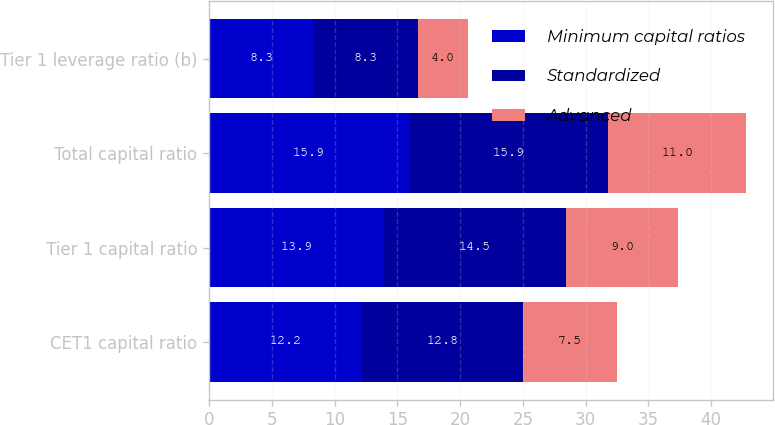Convert chart to OTSL. <chart><loc_0><loc_0><loc_500><loc_500><stacked_bar_chart><ecel><fcel>CET1 capital ratio<fcel>Tier 1 capital ratio<fcel>Total capital ratio<fcel>Tier 1 leverage ratio (b)<nl><fcel>Minimum capital ratios<fcel>12.2<fcel>13.9<fcel>15.9<fcel>8.3<nl><fcel>Standardized<fcel>12.8<fcel>14.5<fcel>15.9<fcel>8.3<nl><fcel>Advanced<fcel>7.5<fcel>9<fcel>11<fcel>4<nl></chart> 